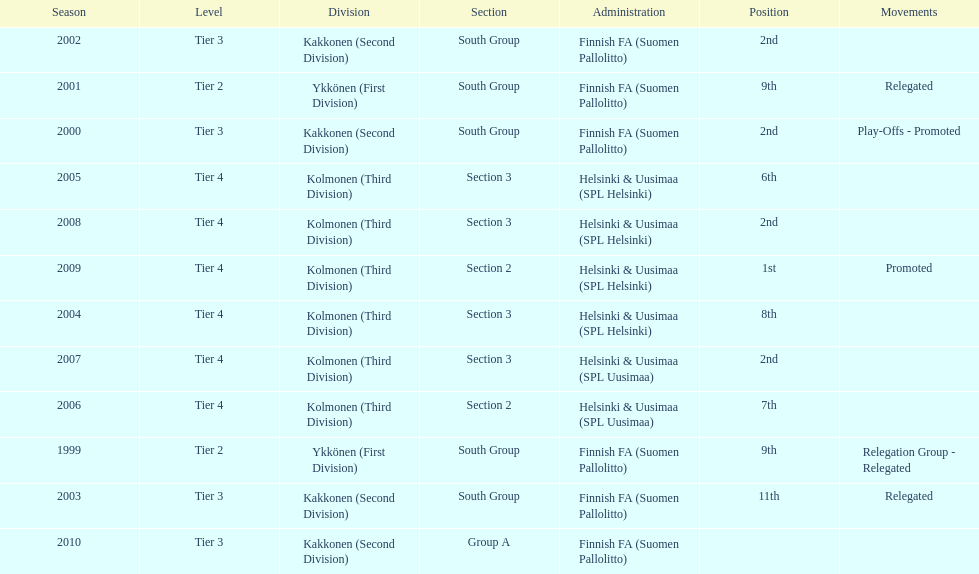Which administration has the least amount of division? Helsinki & Uusimaa (SPL Helsinki). 